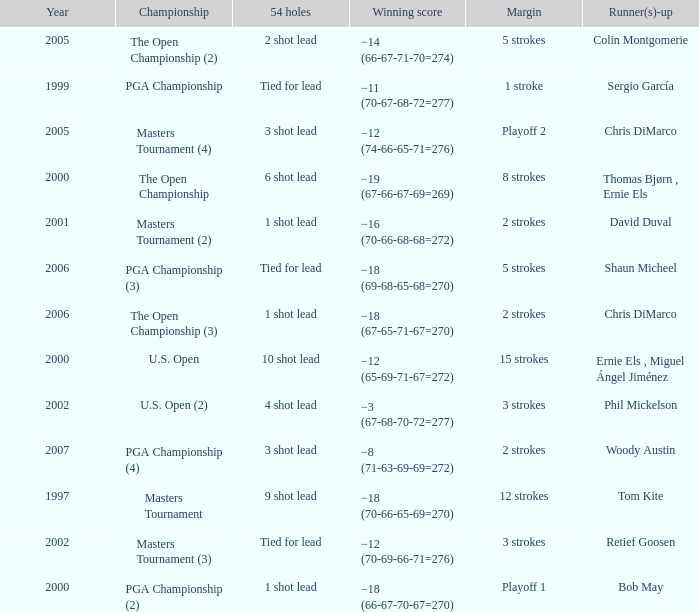 what's the championship where winning score is −12 (74-66-65-71=276) Masters Tournament (4). 